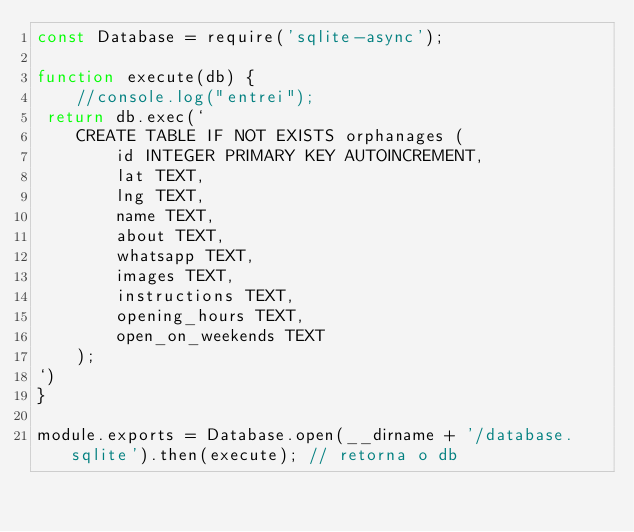<code> <loc_0><loc_0><loc_500><loc_500><_JavaScript_>const Database = require('sqlite-async');

function execute(db) {
    //console.log("entrei");
 return db.exec(`
    CREATE TABLE IF NOT EXISTS orphanages (
        id INTEGER PRIMARY KEY AUTOINCREMENT,
        lat TEXT,
        lng TEXT,
        name TEXT,
        about TEXT,
        whatsapp TEXT,
        images TEXT,
        instructions TEXT,
        opening_hours TEXT,
        open_on_weekends TEXT
    );
`)
}

module.exports = Database.open(__dirname + '/database.sqlite').then(execute); // retorna o db</code> 